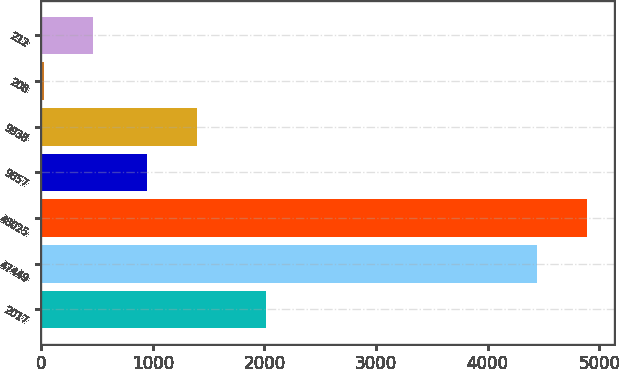<chart> <loc_0><loc_0><loc_500><loc_500><bar_chart><fcel>2017<fcel>47449<fcel>48025<fcel>9857<fcel>9938<fcel>208<fcel>212<nl><fcel>2016<fcel>4440.1<fcel>4886.31<fcel>950.5<fcel>1396.71<fcel>21.4<fcel>467.61<nl></chart> 